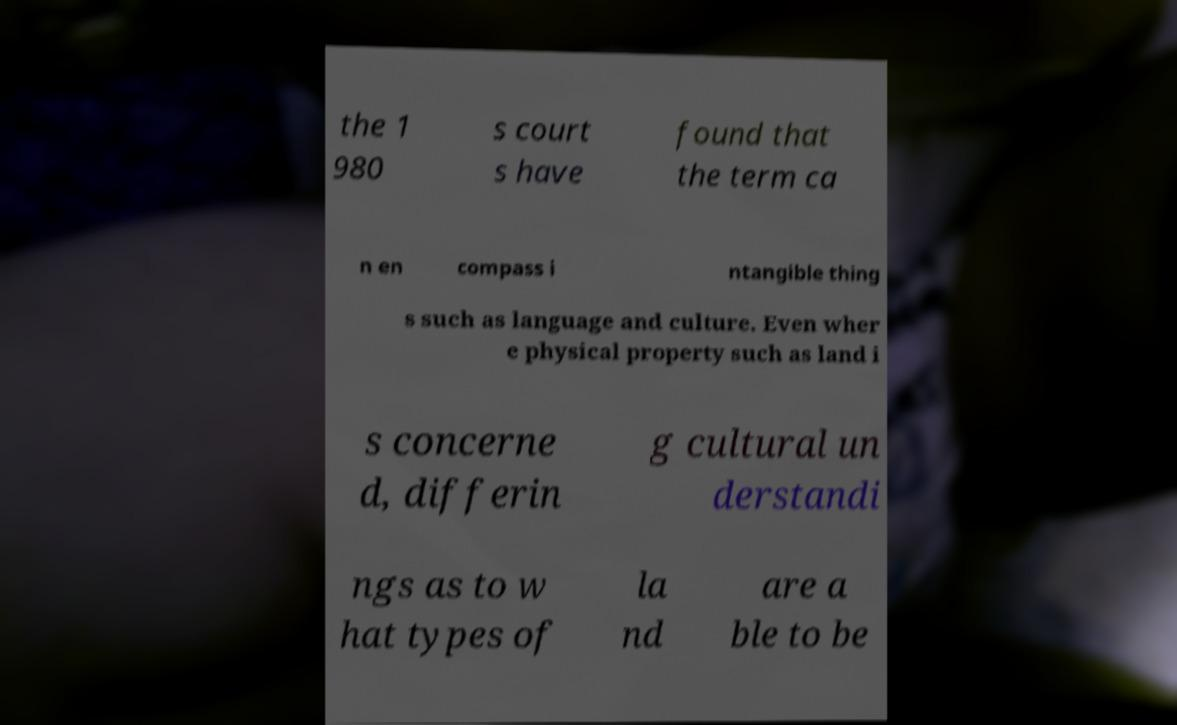There's text embedded in this image that I need extracted. Can you transcribe it verbatim? the 1 980 s court s have found that the term ca n en compass i ntangible thing s such as language and culture. Even wher e physical property such as land i s concerne d, differin g cultural un derstandi ngs as to w hat types of la nd are a ble to be 